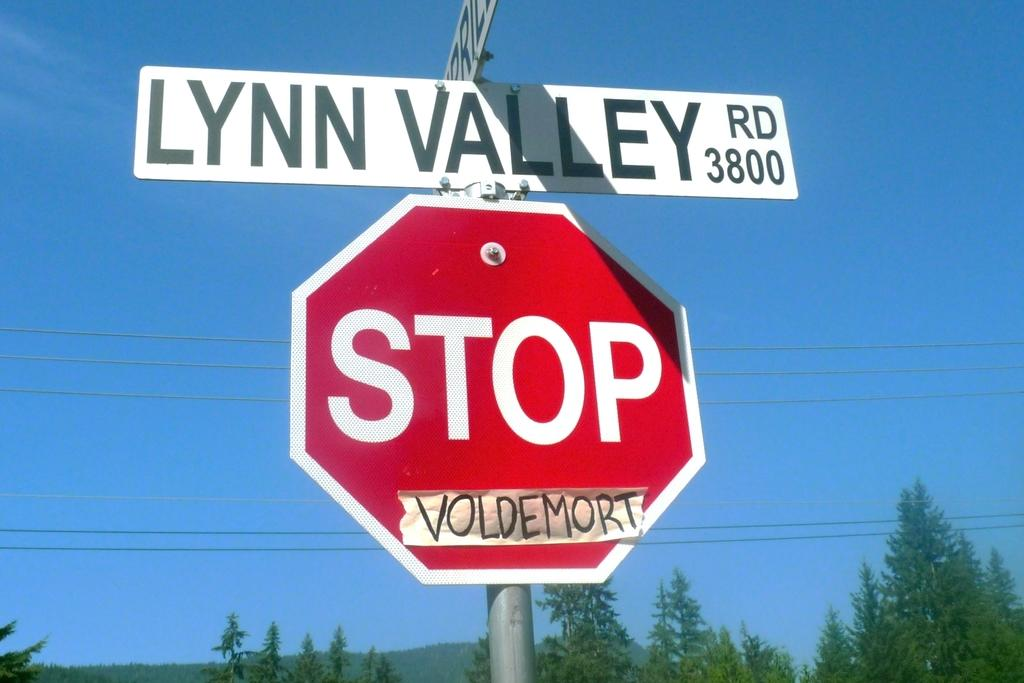Provide a one-sentence caption for the provided image. A stop sign is attached to a pole beneath two perpendicular street signs. 